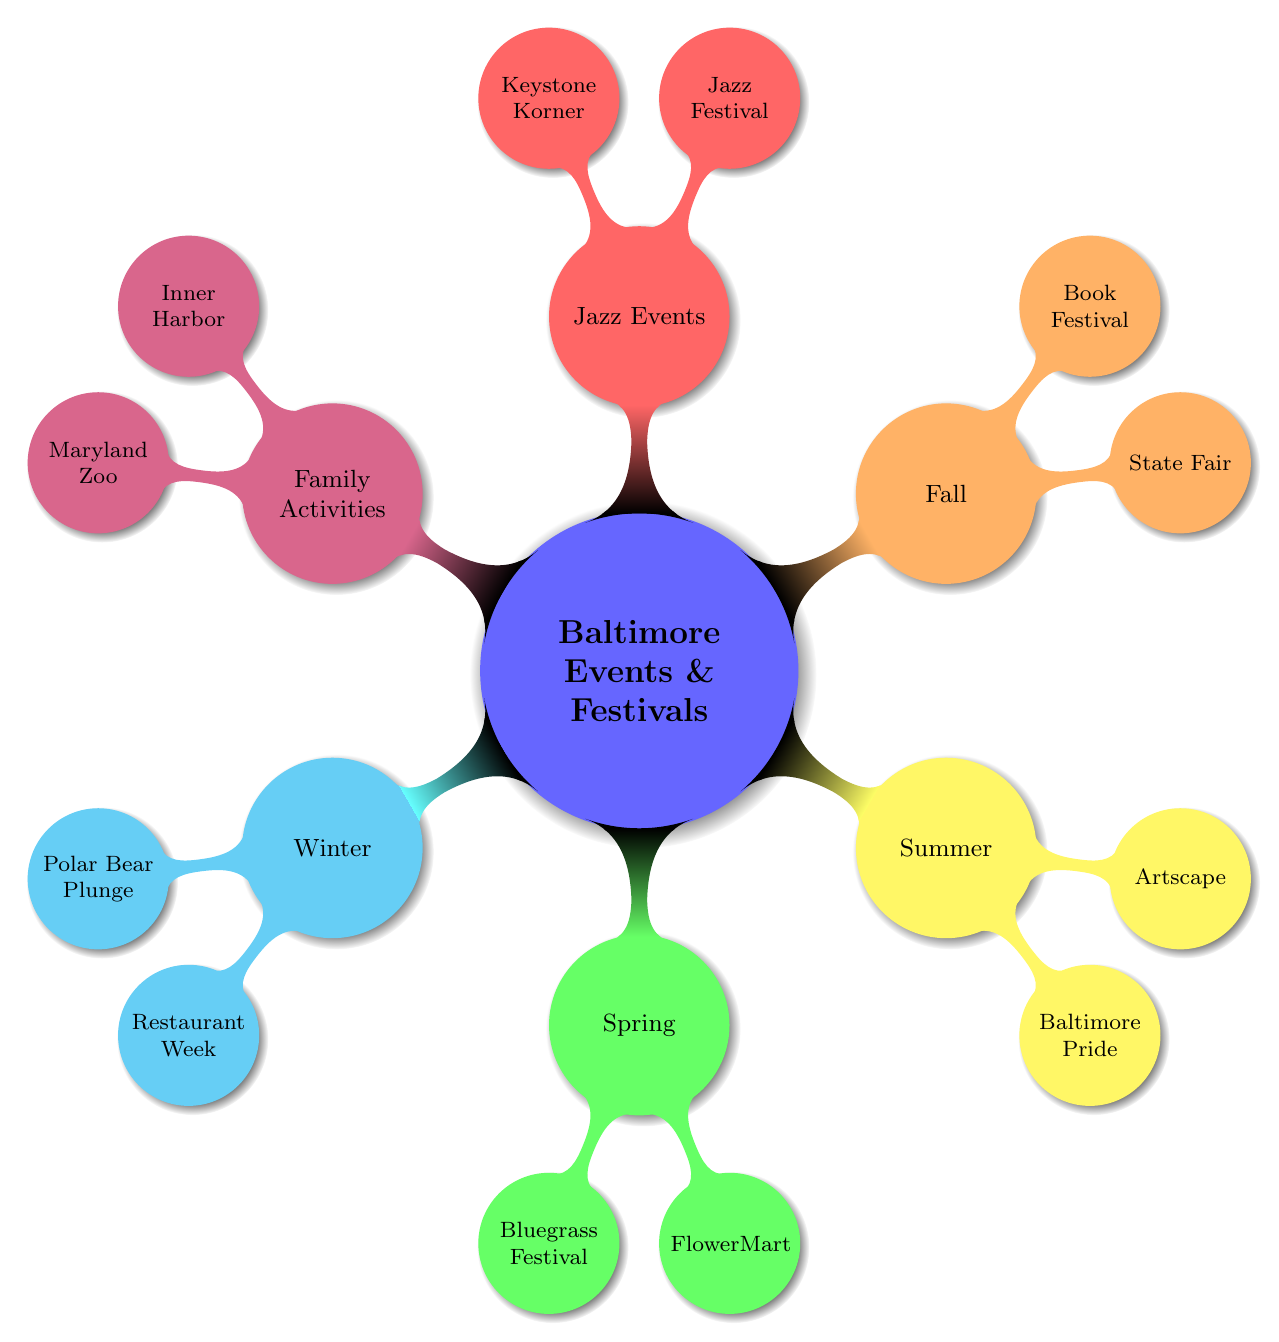What are the events listed under Spring? The diagram shows that the Spring section has two events listed: the Charm City Bluegrass Festival and FlowerMart. By looking at the nodes under the Spring category, we can identify both events.
Answer: Charm City Bluegrass Festival, FlowerMart How many categories of events are there? The main categories in the diagram are Winter, Spring, Summer, Fall, Jazz Events, and Family Activities. Counting these primary branches gives a total of six categories.
Answer: 6 Which event occurs in June? Under the Summer category, the Baltimore Pride event is specifically mentioned to take place in June. By analyzing the events under Summer, we can pinpoint which one is associated with that month.
Answer: Baltimore Pride What is the focus of the Maryland State Fair? The Maryland State Fair is described as a traditional fair featuring agricultural exhibits, amusement rides, and concerts. Reading the details under the Fall node helps to extract specific focuses of the event.
Answer: Agricultural exhibits, amusement rides, concerts Which season does the Baltimore Jazz Festival belong to? The Baltimore Jazz Festival is found under the Jazz Events category, which, in this mind map context, is associated with the season of Fall, when it typically occurs. The festival is listed along with other jazz-related events, there is also a reference to it being in September, which is in Fall.
Answer: Fall What activity can families enjoy year-round in Baltimore? The diagram indicates that the Baltimore Inner Harbor is a family-friendly activity available all year, highlighting its status as a primary attraction. By looking at the Family-Friendly Activities category, we can ascertain its year-round availability.
Answer: Baltimore Inner Harbor Which event happens in February? In the Winter category, the Baltimore Winter Restaurant Week is mentioned as occurring in February. By spotting this event in the Winter section, we can determine its month.
Answer: Baltimore Winter Restaurant Week 